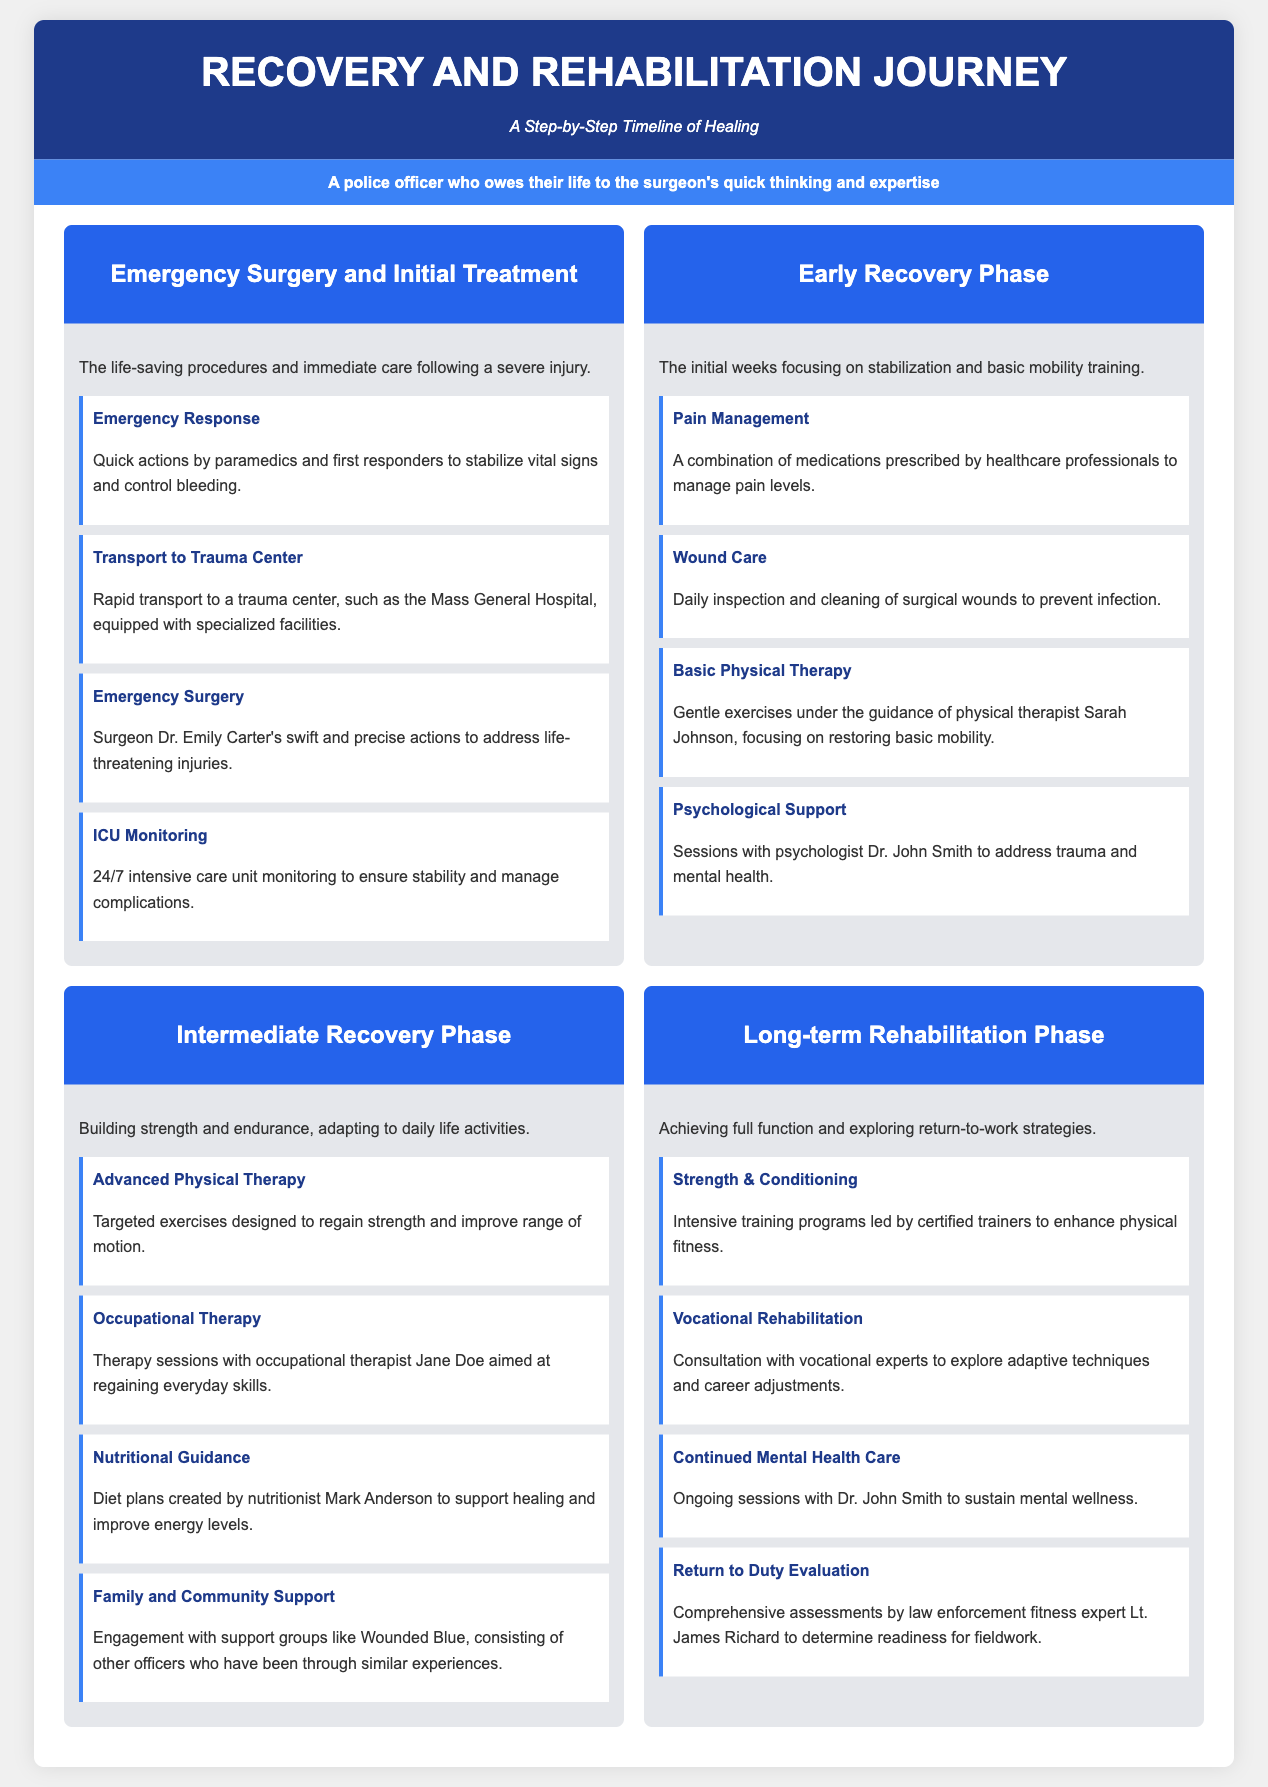What is the title of the document? The title of the document is prominently displayed in the header section.
Answer: Recovery and Rehabilitation Journey Who performed the emergency surgery? The document mentions the surgeon's name in the context of emergency surgery.
Answer: Dr. Emily Carter What type of therapy focuses on regaining everyday skills? This is specified under the Intermediate Recovery Phase in relation to therapy sessions.
Answer: Occupational Therapy How many steps are in the Early Recovery Phase? The document lists the steps under this phase, providing a total count.
Answer: Four Which phase includes sessions with a psychologist? This is mentioned in the context of mental health support within the recovery phases.
Answer: Early Recovery Phase What is the purpose of the Return to Duty Evaluation? This evaluation’s purpose is explained in terms of assessing readiness for fieldwork.
Answer: Determining readiness for fieldwork What does the document provide a timeline of? The document is structured to illustrate a specific journey related to healing processes.
Answer: Healing Who provides nutritional guidance? The document states the name of the professional associated with dietary plans.
Answer: Mark Anderson 